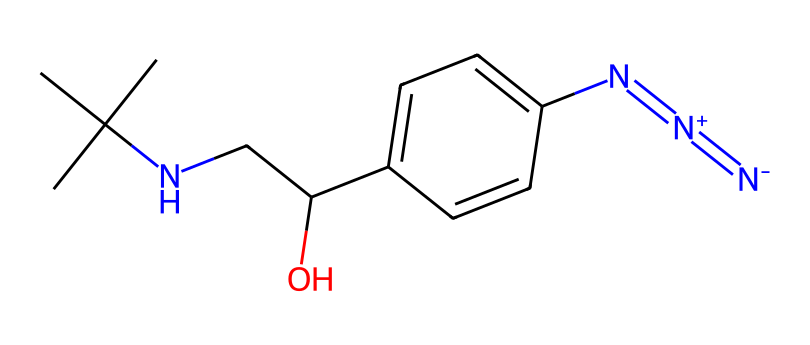How many nitrogen atoms are present in this chemical? By analyzing the SMILES representation, we can identify that there are three nitrogen atoms present in the azide group (N=[N+]=[N-]). Additionally, there is one nitrogen atom in the amine group (NCC). Thus, the total is three plus one.
Answer: four What functional groups are present in this molecule? Observing the structure reveals the presence of an azide functional group (N=[N+]=[N-]), a hydroxyl group (-OH) indicated by NCC(O), and an amine group (–NH) found in the chain.
Answer: azide, hydroxyl, amine Is this chemical likely to be a solid, liquid, or gas at room temperature? Considering the structure, azides, particularly organic azides, tend to be solids due to their large molecular weights and solid crystal structures. The presence of hydroxyl and amine groups suggests hydrogen bonding, stabilizing the solid form further.
Answer: solid What is the purpose of the azide in this chemical? The azide group (N=[N+]=[N-]) often acts as a muscle relaxant and is used to inhibit muscle contraction by interacting with specific receptors in the muscle. This leads to enhanced effects in motor rehabilitation settings by inducing relaxation and reducing tension.
Answer: muscle relaxant What type of reaction might this chemical participate in due to the azide functional group? Azides, due to their unstable nature, can participate in various reactions like nucleophilic substitution or thermal decomposition, producing nitrogen gas and other products. This reaction highlights their potential use in controlled release applications for muscle relaxants.
Answer: nucleophilic substitution 